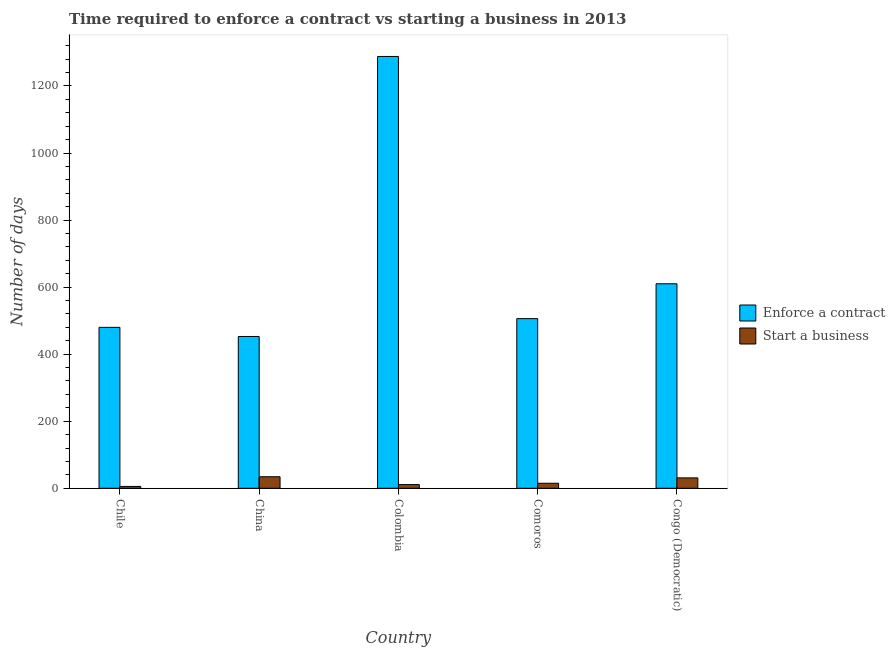How many different coloured bars are there?
Your answer should be compact. 2. How many groups of bars are there?
Offer a terse response. 5. Are the number of bars on each tick of the X-axis equal?
Your answer should be compact. Yes. How many bars are there on the 1st tick from the right?
Give a very brief answer. 2. What is the number of days to start a business in China?
Ensure brevity in your answer.  34.4. Across all countries, what is the maximum number of days to start a business?
Ensure brevity in your answer.  34.4. Across all countries, what is the minimum number of days to enforece a contract?
Your response must be concise. 452.8. In which country was the number of days to enforece a contract maximum?
Offer a very short reply. Colombia. In which country was the number of days to enforece a contract minimum?
Keep it short and to the point. China. What is the total number of days to enforece a contract in the graph?
Keep it short and to the point. 3336.8. What is the difference between the number of days to start a business in Colombia and that in Congo (Democratic)?
Your answer should be very brief. -20. What is the difference between the number of days to enforece a contract in Comoros and the number of days to start a business in Chile?
Keep it short and to the point. 500.5. What is the average number of days to enforece a contract per country?
Keep it short and to the point. 667.36. What is the difference between the number of days to start a business and number of days to enforece a contract in China?
Your answer should be compact. -418.4. What is the ratio of the number of days to start a business in China to that in Congo (Democratic)?
Provide a succinct answer. 1.11. Is the number of days to enforece a contract in Colombia less than that in Congo (Democratic)?
Your answer should be very brief. No. Is the difference between the number of days to enforece a contract in Chile and China greater than the difference between the number of days to start a business in Chile and China?
Make the answer very short. Yes. What is the difference between the highest and the second highest number of days to enforece a contract?
Your answer should be compact. 678. What is the difference between the highest and the lowest number of days to enforece a contract?
Make the answer very short. 835.2. In how many countries, is the number of days to start a business greater than the average number of days to start a business taken over all countries?
Your answer should be very brief. 2. What does the 2nd bar from the left in Comoros represents?
Provide a succinct answer. Start a business. What does the 2nd bar from the right in Congo (Democratic) represents?
Your answer should be compact. Enforce a contract. How many bars are there?
Give a very brief answer. 10. Are the values on the major ticks of Y-axis written in scientific E-notation?
Ensure brevity in your answer.  No. Does the graph contain any zero values?
Keep it short and to the point. No. Does the graph contain grids?
Offer a terse response. No. How many legend labels are there?
Provide a short and direct response. 2. How are the legend labels stacked?
Provide a succinct answer. Vertical. What is the title of the graph?
Keep it short and to the point. Time required to enforce a contract vs starting a business in 2013. Does "Age 65(male)" appear as one of the legend labels in the graph?
Offer a very short reply. No. What is the label or title of the X-axis?
Your answer should be compact. Country. What is the label or title of the Y-axis?
Keep it short and to the point. Number of days. What is the Number of days of Enforce a contract in Chile?
Provide a short and direct response. 480. What is the Number of days in Start a business in Chile?
Provide a succinct answer. 5.5. What is the Number of days in Enforce a contract in China?
Your response must be concise. 452.8. What is the Number of days in Start a business in China?
Provide a short and direct response. 34.4. What is the Number of days in Enforce a contract in Colombia?
Give a very brief answer. 1288. What is the Number of days in Start a business in Colombia?
Offer a terse response. 11. What is the Number of days in Enforce a contract in Comoros?
Offer a very short reply. 506. What is the Number of days in Enforce a contract in Congo (Democratic)?
Offer a very short reply. 610. Across all countries, what is the maximum Number of days in Enforce a contract?
Offer a terse response. 1288. Across all countries, what is the maximum Number of days of Start a business?
Give a very brief answer. 34.4. Across all countries, what is the minimum Number of days in Enforce a contract?
Offer a very short reply. 452.8. What is the total Number of days of Enforce a contract in the graph?
Make the answer very short. 3336.8. What is the total Number of days of Start a business in the graph?
Give a very brief answer. 96.9. What is the difference between the Number of days of Enforce a contract in Chile and that in China?
Offer a terse response. 27.2. What is the difference between the Number of days in Start a business in Chile and that in China?
Give a very brief answer. -28.9. What is the difference between the Number of days of Enforce a contract in Chile and that in Colombia?
Make the answer very short. -808. What is the difference between the Number of days of Enforce a contract in Chile and that in Congo (Democratic)?
Keep it short and to the point. -130. What is the difference between the Number of days of Start a business in Chile and that in Congo (Democratic)?
Make the answer very short. -25.5. What is the difference between the Number of days in Enforce a contract in China and that in Colombia?
Give a very brief answer. -835.2. What is the difference between the Number of days in Start a business in China and that in Colombia?
Provide a short and direct response. 23.4. What is the difference between the Number of days in Enforce a contract in China and that in Comoros?
Provide a succinct answer. -53.2. What is the difference between the Number of days of Start a business in China and that in Comoros?
Offer a very short reply. 19.4. What is the difference between the Number of days in Enforce a contract in China and that in Congo (Democratic)?
Provide a succinct answer. -157.2. What is the difference between the Number of days of Start a business in China and that in Congo (Democratic)?
Your response must be concise. 3.4. What is the difference between the Number of days of Enforce a contract in Colombia and that in Comoros?
Give a very brief answer. 782. What is the difference between the Number of days in Start a business in Colombia and that in Comoros?
Make the answer very short. -4. What is the difference between the Number of days in Enforce a contract in Colombia and that in Congo (Democratic)?
Keep it short and to the point. 678. What is the difference between the Number of days in Enforce a contract in Comoros and that in Congo (Democratic)?
Your response must be concise. -104. What is the difference between the Number of days in Start a business in Comoros and that in Congo (Democratic)?
Offer a terse response. -16. What is the difference between the Number of days of Enforce a contract in Chile and the Number of days of Start a business in China?
Keep it short and to the point. 445.6. What is the difference between the Number of days in Enforce a contract in Chile and the Number of days in Start a business in Colombia?
Your answer should be compact. 469. What is the difference between the Number of days in Enforce a contract in Chile and the Number of days in Start a business in Comoros?
Your answer should be very brief. 465. What is the difference between the Number of days in Enforce a contract in Chile and the Number of days in Start a business in Congo (Democratic)?
Provide a short and direct response. 449. What is the difference between the Number of days of Enforce a contract in China and the Number of days of Start a business in Colombia?
Provide a short and direct response. 441.8. What is the difference between the Number of days in Enforce a contract in China and the Number of days in Start a business in Comoros?
Your answer should be very brief. 437.8. What is the difference between the Number of days of Enforce a contract in China and the Number of days of Start a business in Congo (Democratic)?
Keep it short and to the point. 421.8. What is the difference between the Number of days in Enforce a contract in Colombia and the Number of days in Start a business in Comoros?
Keep it short and to the point. 1273. What is the difference between the Number of days in Enforce a contract in Colombia and the Number of days in Start a business in Congo (Democratic)?
Offer a very short reply. 1257. What is the difference between the Number of days in Enforce a contract in Comoros and the Number of days in Start a business in Congo (Democratic)?
Ensure brevity in your answer.  475. What is the average Number of days in Enforce a contract per country?
Ensure brevity in your answer.  667.36. What is the average Number of days in Start a business per country?
Provide a short and direct response. 19.38. What is the difference between the Number of days in Enforce a contract and Number of days in Start a business in Chile?
Make the answer very short. 474.5. What is the difference between the Number of days of Enforce a contract and Number of days of Start a business in China?
Offer a very short reply. 418.4. What is the difference between the Number of days in Enforce a contract and Number of days in Start a business in Colombia?
Offer a terse response. 1277. What is the difference between the Number of days in Enforce a contract and Number of days in Start a business in Comoros?
Make the answer very short. 491. What is the difference between the Number of days of Enforce a contract and Number of days of Start a business in Congo (Democratic)?
Make the answer very short. 579. What is the ratio of the Number of days in Enforce a contract in Chile to that in China?
Give a very brief answer. 1.06. What is the ratio of the Number of days of Start a business in Chile to that in China?
Provide a succinct answer. 0.16. What is the ratio of the Number of days of Enforce a contract in Chile to that in Colombia?
Provide a short and direct response. 0.37. What is the ratio of the Number of days in Start a business in Chile to that in Colombia?
Provide a short and direct response. 0.5. What is the ratio of the Number of days of Enforce a contract in Chile to that in Comoros?
Offer a very short reply. 0.95. What is the ratio of the Number of days of Start a business in Chile to that in Comoros?
Offer a very short reply. 0.37. What is the ratio of the Number of days in Enforce a contract in Chile to that in Congo (Democratic)?
Your answer should be compact. 0.79. What is the ratio of the Number of days of Start a business in Chile to that in Congo (Democratic)?
Your answer should be compact. 0.18. What is the ratio of the Number of days of Enforce a contract in China to that in Colombia?
Ensure brevity in your answer.  0.35. What is the ratio of the Number of days in Start a business in China to that in Colombia?
Provide a short and direct response. 3.13. What is the ratio of the Number of days of Enforce a contract in China to that in Comoros?
Give a very brief answer. 0.89. What is the ratio of the Number of days in Start a business in China to that in Comoros?
Offer a terse response. 2.29. What is the ratio of the Number of days of Enforce a contract in China to that in Congo (Democratic)?
Offer a very short reply. 0.74. What is the ratio of the Number of days of Start a business in China to that in Congo (Democratic)?
Give a very brief answer. 1.11. What is the ratio of the Number of days of Enforce a contract in Colombia to that in Comoros?
Provide a short and direct response. 2.55. What is the ratio of the Number of days of Start a business in Colombia to that in Comoros?
Offer a very short reply. 0.73. What is the ratio of the Number of days in Enforce a contract in Colombia to that in Congo (Democratic)?
Ensure brevity in your answer.  2.11. What is the ratio of the Number of days in Start a business in Colombia to that in Congo (Democratic)?
Your answer should be compact. 0.35. What is the ratio of the Number of days of Enforce a contract in Comoros to that in Congo (Democratic)?
Your response must be concise. 0.83. What is the ratio of the Number of days in Start a business in Comoros to that in Congo (Democratic)?
Offer a very short reply. 0.48. What is the difference between the highest and the second highest Number of days of Enforce a contract?
Provide a succinct answer. 678. What is the difference between the highest and the second highest Number of days of Start a business?
Keep it short and to the point. 3.4. What is the difference between the highest and the lowest Number of days in Enforce a contract?
Your response must be concise. 835.2. What is the difference between the highest and the lowest Number of days of Start a business?
Provide a short and direct response. 28.9. 